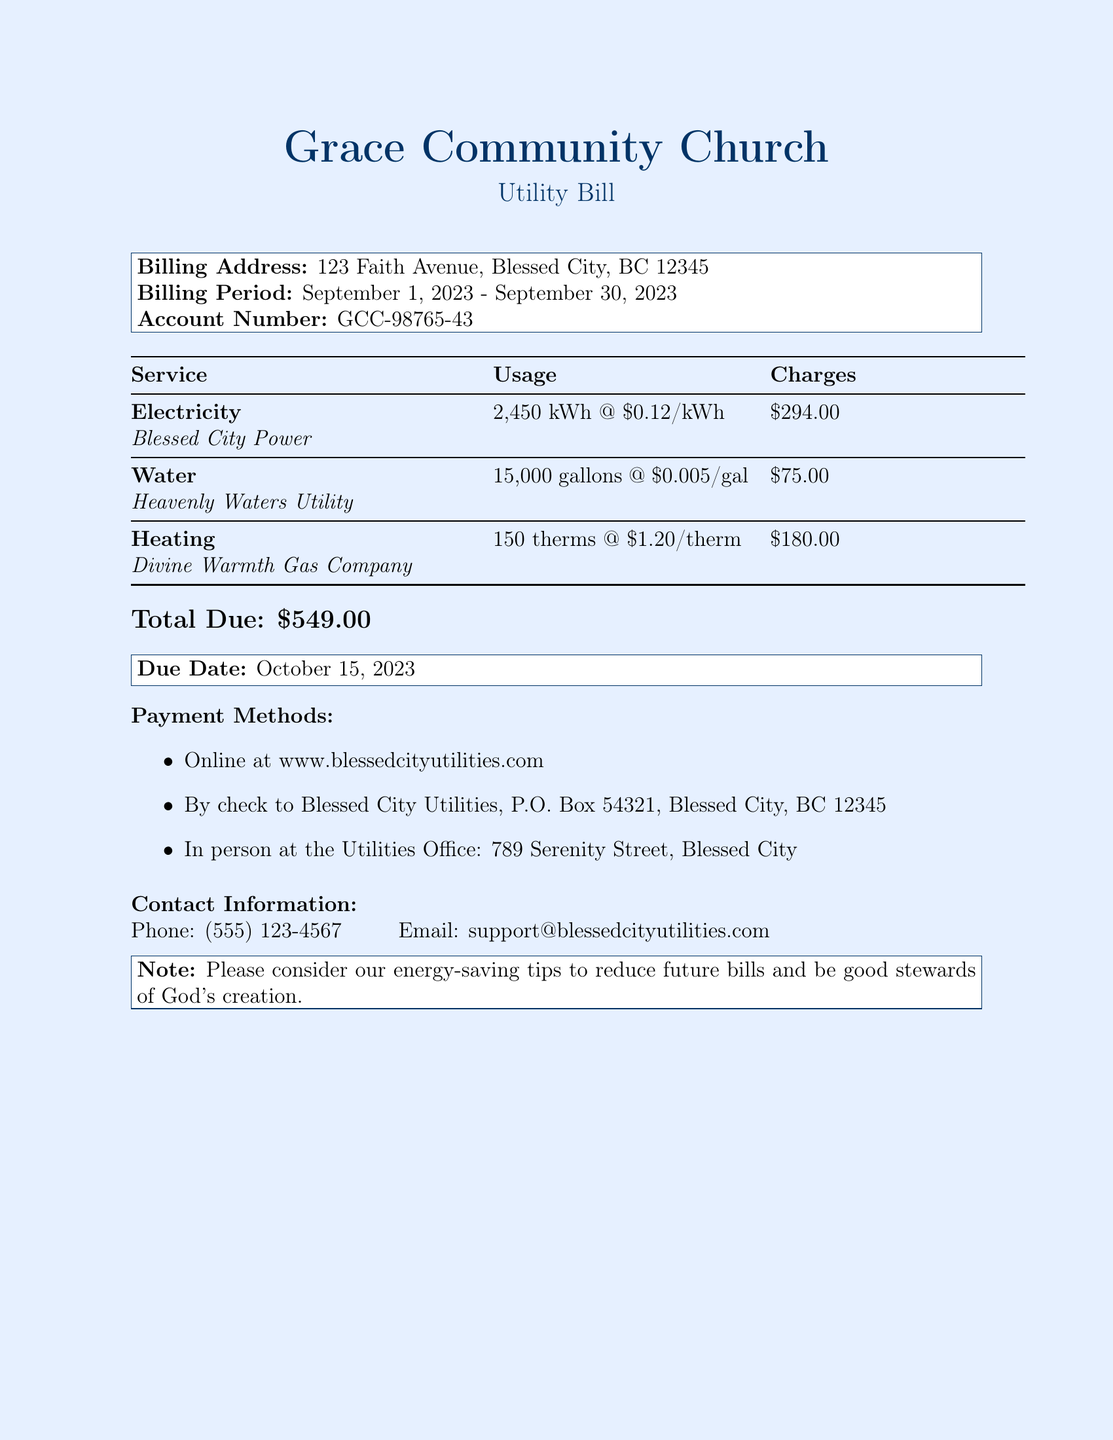What is the billing address? The billing address is clearly stated in the document, which is 123 Faith Avenue, Blessed City, BC 12345.
Answer: 123 Faith Avenue, Blessed City, BC 12345 What is the total due amount? The total due is presented at the bottom of the document, which sums up all the individual charges.
Answer: $549.00 What is the billing period? The billing period indicates the time frame for which the charges apply, which is from September 1, 2023 to September 30, 2023.
Answer: September 1, 2023 - September 30, 2023 How much is charged for electricity? The electricity charge can be found under the electricity section of the breakdown.
Answer: $294.00 What is the due date for the bill? The due date is noted specifically in a box towards the end of the document.
Answer: October 15, 2023 What is the usage for water? The document indicates the amount of water used during the billing period.
Answer: 15,000 gallons How much is charged for heating per therm? This detail is given in the heating breakdown where the rate per therm is listed.
Answer: $1.20/therm Name one payment method listed in the document. The document specifies several methods of payment that can be chosen.
Answer: Online at www.blessedcityutilities.com How many therms of heating were used? The amount of heating used is presented in the heating section.
Answer: 150 therms 